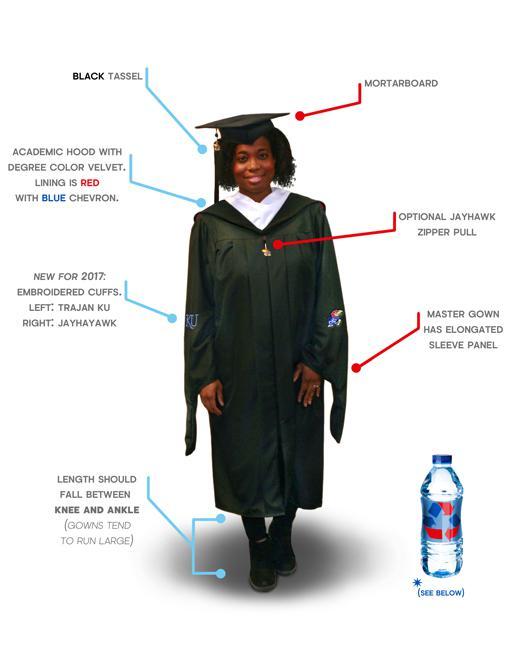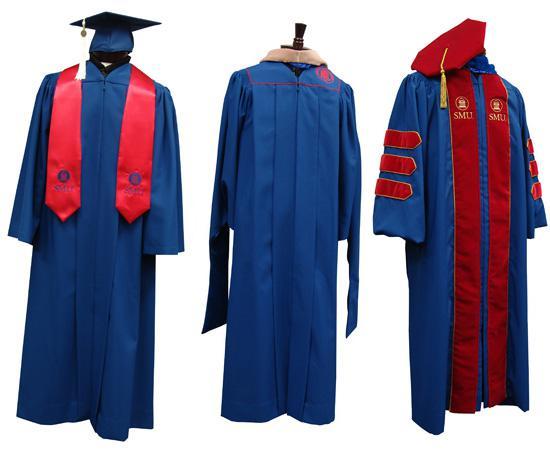The first image is the image on the left, the second image is the image on the right. Assess this claim about the two images: "The hood of the robe in one image features a floral pattern rather than a solid color.". Correct or not? Answer yes or no. No. The first image is the image on the left, the second image is the image on the right. Analyze the images presented: Is the assertion "There are two views of a person who is where a red sash and black graduation robe." valid? Answer yes or no. No. 